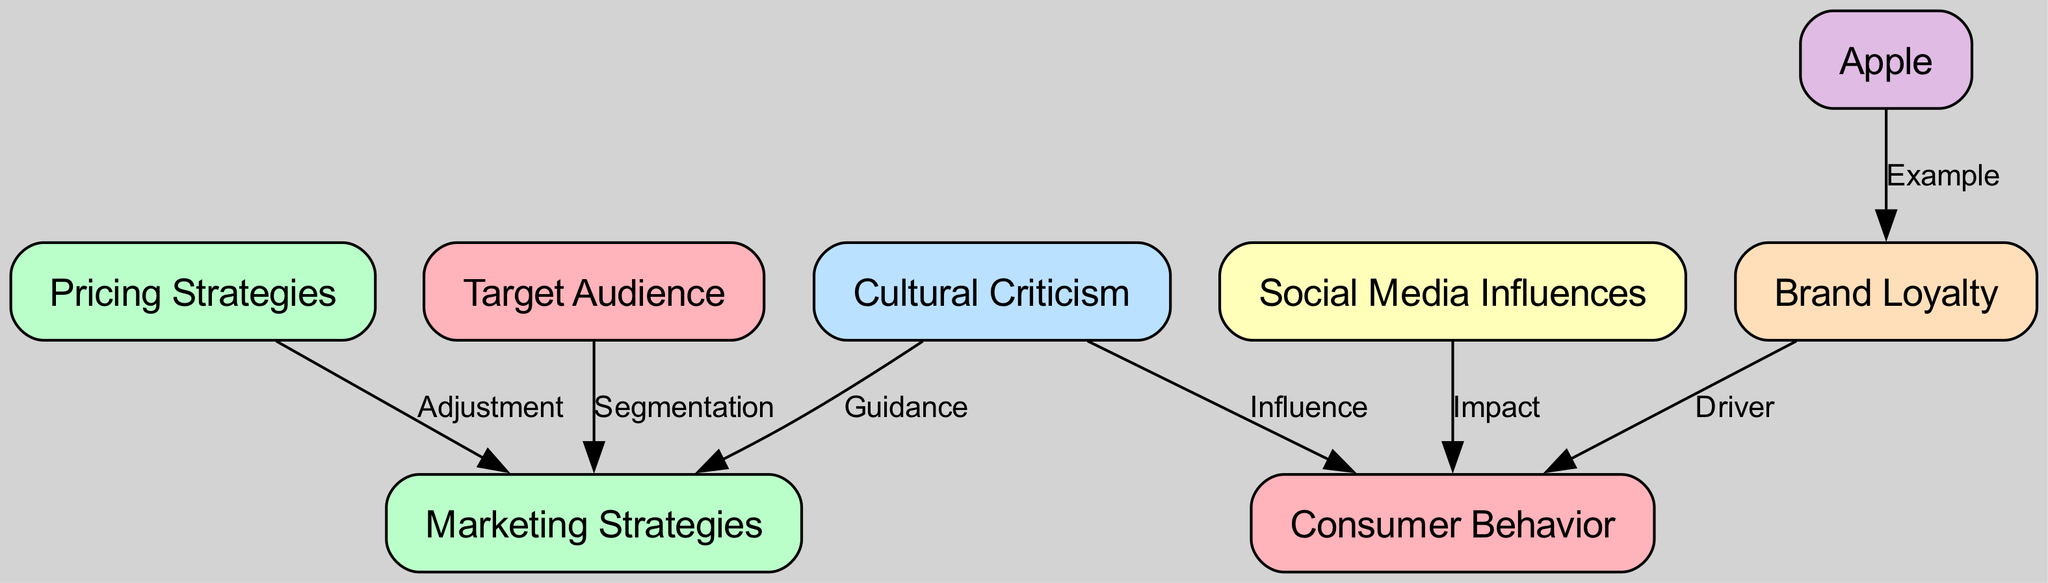What is the total number of nodes in the diagram? The diagram lists several nodes, identified by their corresponding IDs, including consumer behavior, marketing strategies, cultural criticism, social media influences, brand loyalty, Apple, target audience, and pricing strategies. Counting these gives a total of 8 nodes.
Answer: 8 Which node leads to consumer behavior based on cultural criticism? The edge from cultural criticism to consumer behavior indicates that cultural norms have a direct influence on how consumers decide on purchases. Thus, cultural criticism leads to consumer behavior.
Answer: cultural criticism What type of influence does social media have on consumer behavior? There is an edge from social media influences to consumer behavior, labeled "Impact." This indicates that social media trends actively shape consumer behavior.
Answer: Impact How many edges are present in the diagram? By reviewing the connections (edges) between nodes, we can count that there are 7 edges established, connecting various nodes together, representing the flow of influence and relationships.
Answer: 7 Which node represents a tech company known for strong cultural influence? Among the nodes, "Apple" is specifically mentioned as an example of a tech company that demonstrates significant cultural influence on consumer loyalty.
Answer: Apple What does brand loyalty drive in consumer behavior? Examining the connection from brand loyalty to consumer behavior shows that brand loyalty acts as a driver, indicating that cultural identity can enhance consumer loyalty to specific tech brands.
Answer: Driver How does marketing strategies relate to target audience? The relationship between the target audience and marketing strategies is defined by an edge labeled "Segmentation." This suggests that marketing strategies are tailored to fit different cultural segments of the target audience.
Answer: Segmentation What is indicated by the influence of pricing strategies on marketing strategies? The diagram shows an edge from pricing strategies to marketing strategies labeled "Adjustment." This reflects how tech companies adjust their pricing based on perceived cultural value and other factors.
Answer: Adjustment 